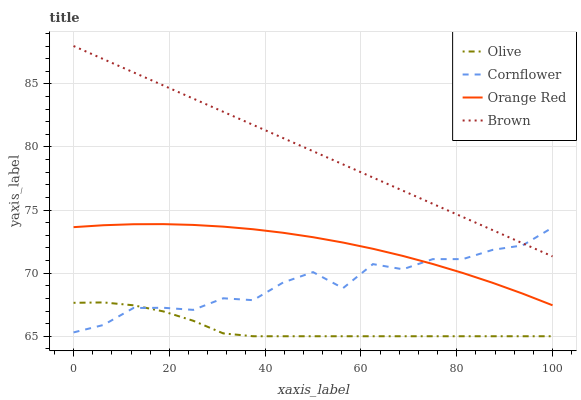Does Olive have the minimum area under the curve?
Answer yes or no. Yes. Does Brown have the maximum area under the curve?
Answer yes or no. Yes. Does Cornflower have the minimum area under the curve?
Answer yes or no. No. Does Cornflower have the maximum area under the curve?
Answer yes or no. No. Is Brown the smoothest?
Answer yes or no. Yes. Is Cornflower the roughest?
Answer yes or no. Yes. Is Orange Red the smoothest?
Answer yes or no. No. Is Orange Red the roughest?
Answer yes or no. No. Does Cornflower have the lowest value?
Answer yes or no. No. Does Brown have the highest value?
Answer yes or no. Yes. Does Cornflower have the highest value?
Answer yes or no. No. Is Olive less than Brown?
Answer yes or no. Yes. Is Brown greater than Orange Red?
Answer yes or no. Yes. Does Cornflower intersect Brown?
Answer yes or no. Yes. Is Cornflower less than Brown?
Answer yes or no. No. Is Cornflower greater than Brown?
Answer yes or no. No. Does Olive intersect Brown?
Answer yes or no. No. 